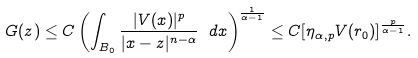<formula> <loc_0><loc_0><loc_500><loc_500>G ( z ) \leq C \left ( \int _ { B _ { 0 } } \frac { | V ( x ) | ^ { p } } { | x - z | ^ { n - \alpha } } \ d x \right ) ^ { \frac { 1 } { ^ { \alpha - 1 } } } \leq C [ \eta _ { \alpha , p } V ( r _ { 0 } ) ] ^ { \frac { p } { \alpha - 1 } } .</formula> 